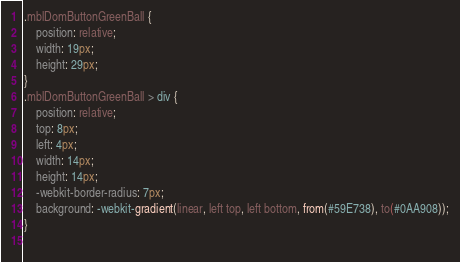Convert code to text. <code><loc_0><loc_0><loc_500><loc_500><_CSS_>
.mblDomButtonGreenBall {
	position: relative;
	width: 19px;
	height: 29px;
}
.mblDomButtonGreenBall > div {
	position: relative;
	top: 8px;
	left: 4px;
	width: 14px;
	height: 14px;
	-webkit-border-radius: 7px;
	background: -webkit-gradient(linear, left top, left bottom, from(#59E738), to(#0AA908));
}
 </code> 